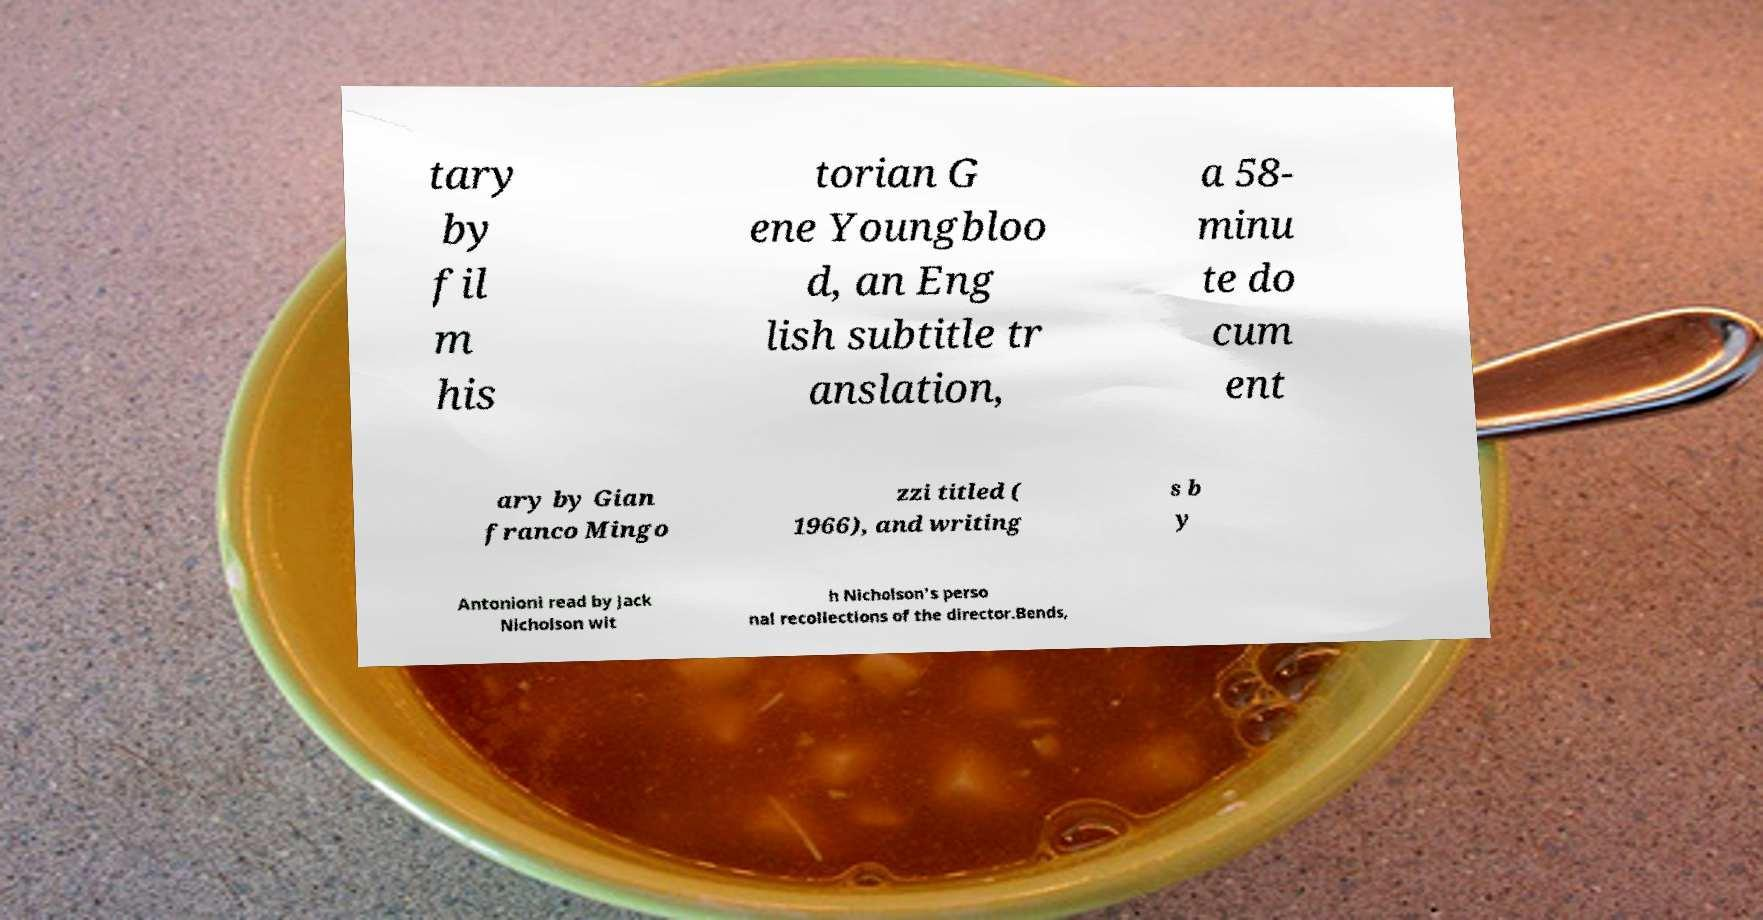I need the written content from this picture converted into text. Can you do that? tary by fil m his torian G ene Youngbloo d, an Eng lish subtitle tr anslation, a 58- minu te do cum ent ary by Gian franco Mingo zzi titled ( 1966), and writing s b y Antonioni read by Jack Nicholson wit h Nicholson's perso nal recollections of the director.Bends, 